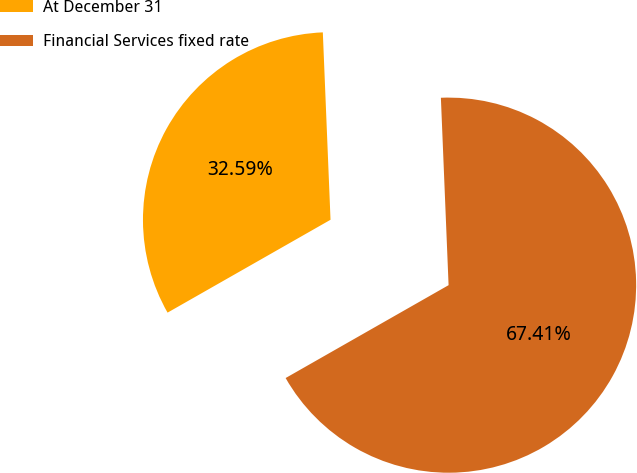Convert chart. <chart><loc_0><loc_0><loc_500><loc_500><pie_chart><fcel>At December 31<fcel>Financial Services fixed rate<nl><fcel>32.59%<fcel>67.41%<nl></chart> 